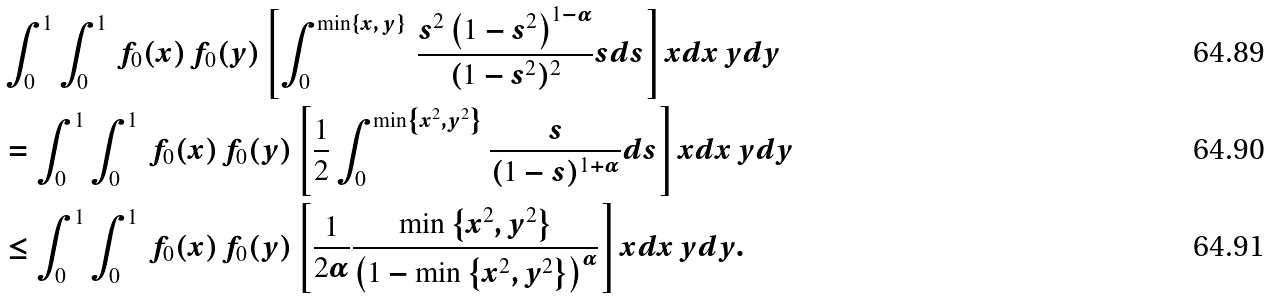Convert formula to latex. <formula><loc_0><loc_0><loc_500><loc_500>& \int _ { 0 } ^ { 1 } \int _ { 0 } ^ { 1 } \, f _ { 0 } ( x ) \, f _ { 0 } ( y ) \left [ \int _ { 0 } ^ { \min \left \{ x , \, y \right \} } \, { \frac { s ^ { 2 } \left ( 1 - s ^ { 2 } \right ) ^ { 1 - \alpha } } { ( 1 - s ^ { 2 } ) ^ { 2 } } s d s } \right ] x d x \, y d y \\ & = \int _ { 0 } ^ { 1 } \int _ { 0 } ^ { 1 } \, f _ { 0 } ( x ) \, f _ { 0 } ( y ) \left [ \frac { 1 } { 2 } \int _ { 0 } ^ { \min \left \{ x ^ { 2 } , y ^ { 2 } \right \} } \frac { s } { ( 1 - s ) ^ { 1 + \alpha } } d s \right ] x d x \, y d y \\ & \leq \int _ { 0 } ^ { 1 } \int _ { 0 } ^ { 1 } \, f _ { 0 } ( x ) \, f _ { 0 } ( y ) \left [ \frac { 1 } { 2 \alpha } \frac { \min \left \{ x ^ { 2 } , y ^ { 2 } \right \} } { \left ( 1 - \min \left \{ x ^ { 2 } , y ^ { 2 } \right \} \right ) ^ { \alpha } } \right ] x d x \, y d y .</formula> 